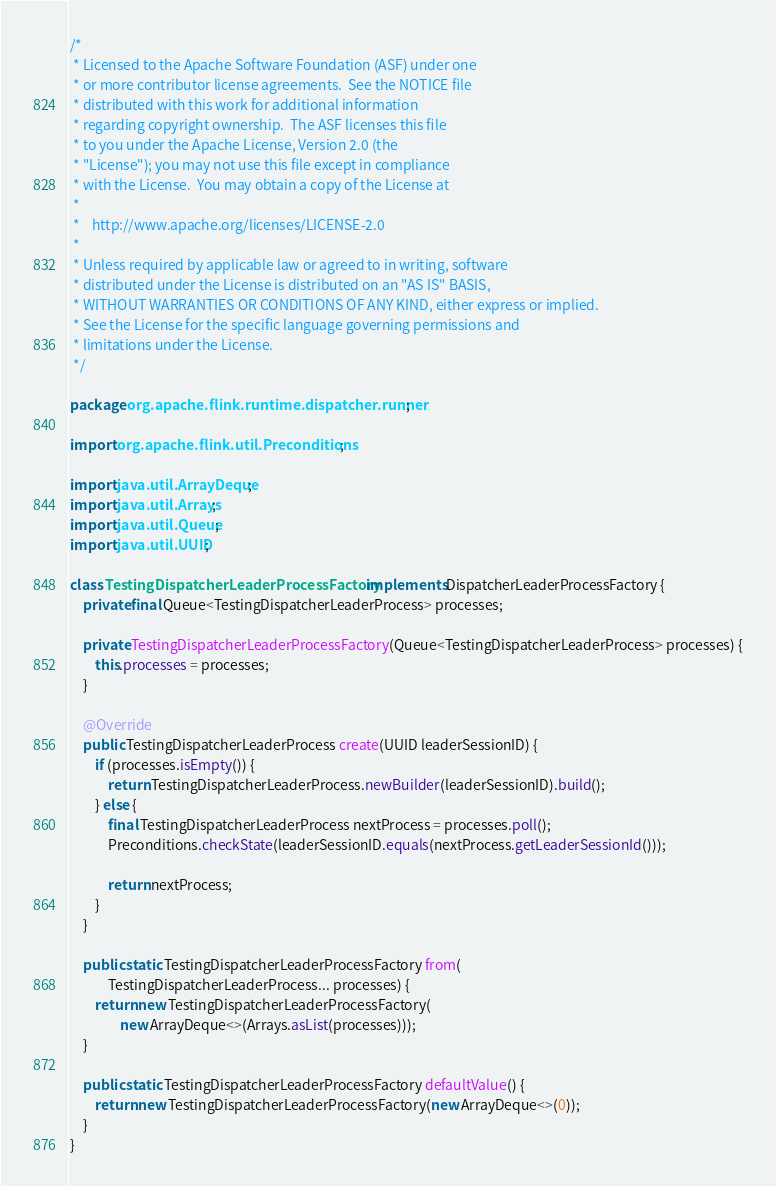Convert code to text. <code><loc_0><loc_0><loc_500><loc_500><_Java_>/*
 * Licensed to the Apache Software Foundation (ASF) under one
 * or more contributor license agreements.  See the NOTICE file
 * distributed with this work for additional information
 * regarding copyright ownership.  The ASF licenses this file
 * to you under the Apache License, Version 2.0 (the
 * "License"); you may not use this file except in compliance
 * with the License.  You may obtain a copy of the License at
 *
 *    http://www.apache.org/licenses/LICENSE-2.0
 *
 * Unless required by applicable law or agreed to in writing, software
 * distributed under the License is distributed on an "AS IS" BASIS,
 * WITHOUT WARRANTIES OR CONDITIONS OF ANY KIND, either express or implied.
 * See the License for the specific language governing permissions and
 * limitations under the License.
 */

package org.apache.flink.runtime.dispatcher.runner;

import org.apache.flink.util.Preconditions;

import java.util.ArrayDeque;
import java.util.Arrays;
import java.util.Queue;
import java.util.UUID;

class TestingDispatcherLeaderProcessFactory implements DispatcherLeaderProcessFactory {
    private final Queue<TestingDispatcherLeaderProcess> processes;

    private TestingDispatcherLeaderProcessFactory(Queue<TestingDispatcherLeaderProcess> processes) {
        this.processes = processes;
    }

    @Override
    public TestingDispatcherLeaderProcess create(UUID leaderSessionID) {
        if (processes.isEmpty()) {
            return TestingDispatcherLeaderProcess.newBuilder(leaderSessionID).build();
        } else {
            final TestingDispatcherLeaderProcess nextProcess = processes.poll();
            Preconditions.checkState(leaderSessionID.equals(nextProcess.getLeaderSessionId()));

            return nextProcess;
        }
    }

    public static TestingDispatcherLeaderProcessFactory from(
            TestingDispatcherLeaderProcess... processes) {
        return new TestingDispatcherLeaderProcessFactory(
                new ArrayDeque<>(Arrays.asList(processes)));
    }

    public static TestingDispatcherLeaderProcessFactory defaultValue() {
        return new TestingDispatcherLeaderProcessFactory(new ArrayDeque<>(0));
    }
}
</code> 